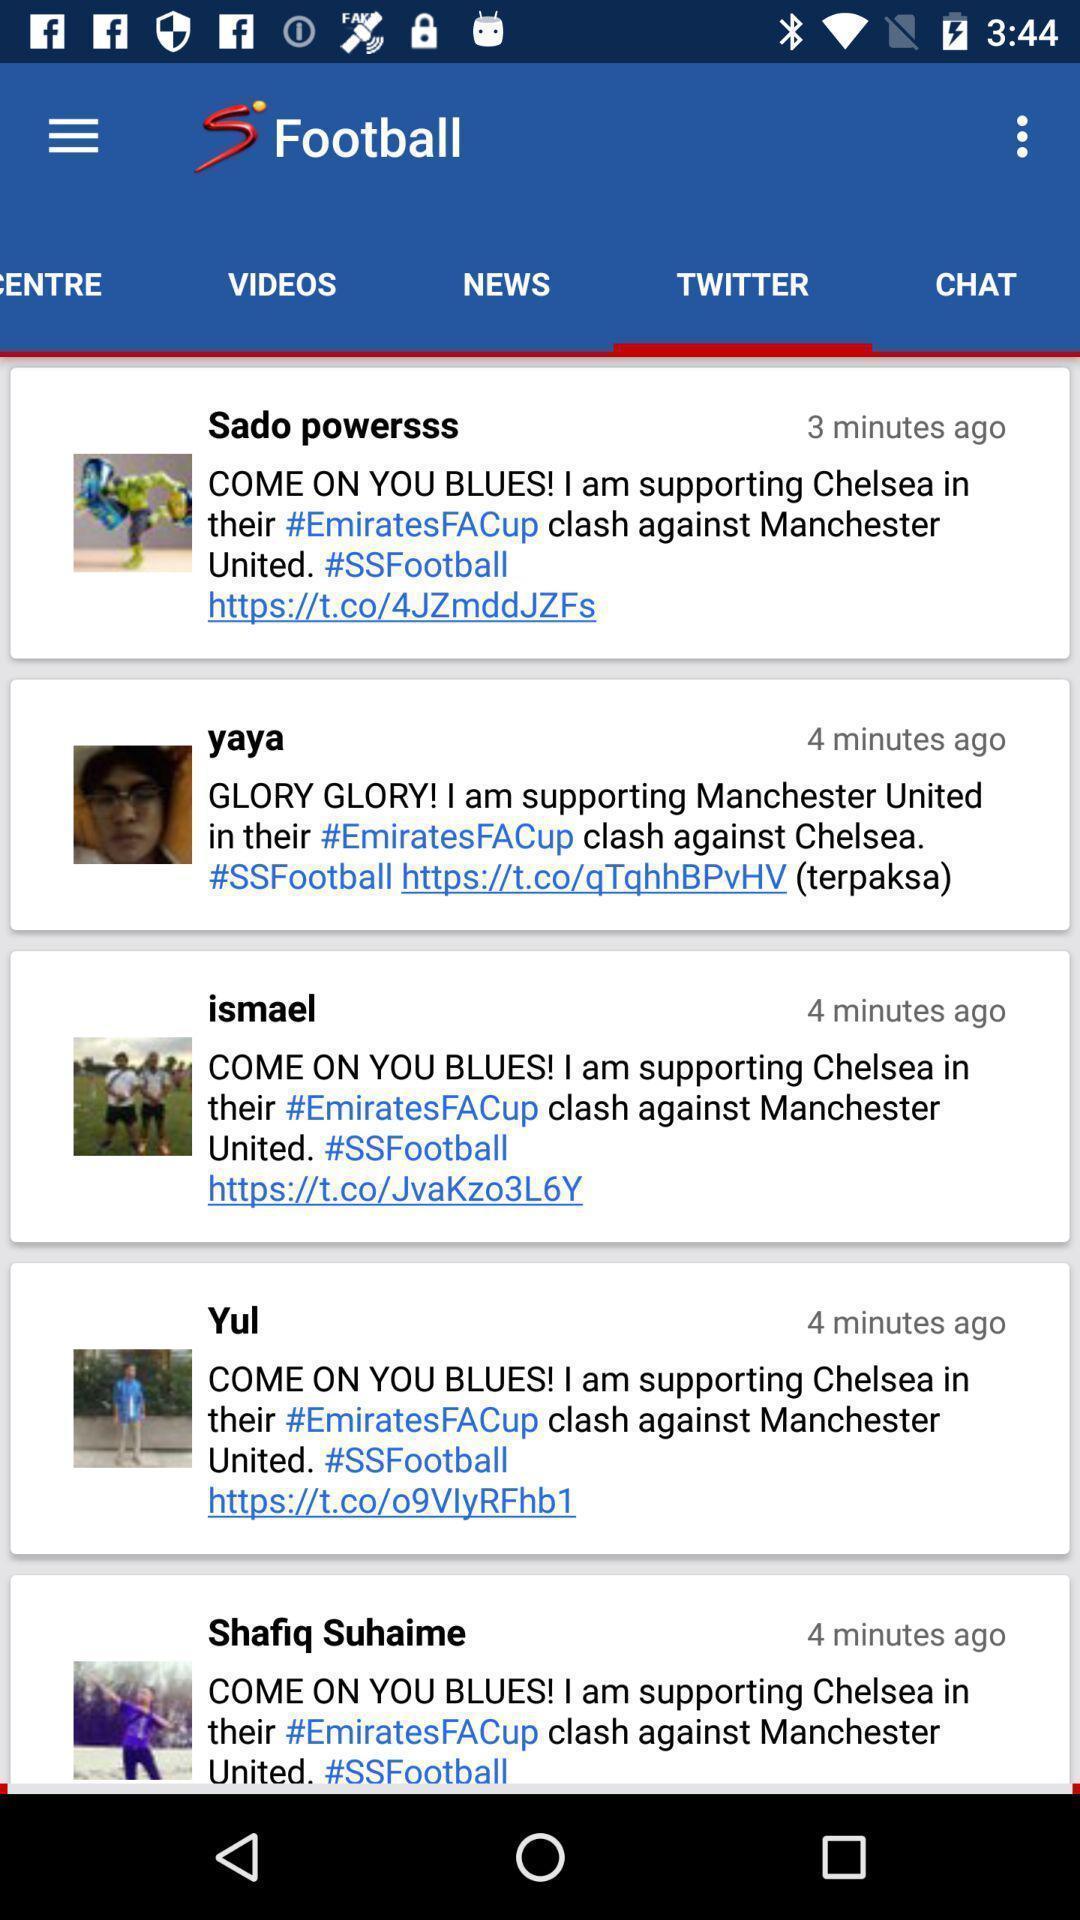Explain the elements present in this screenshot. Page that displaying sports application. 